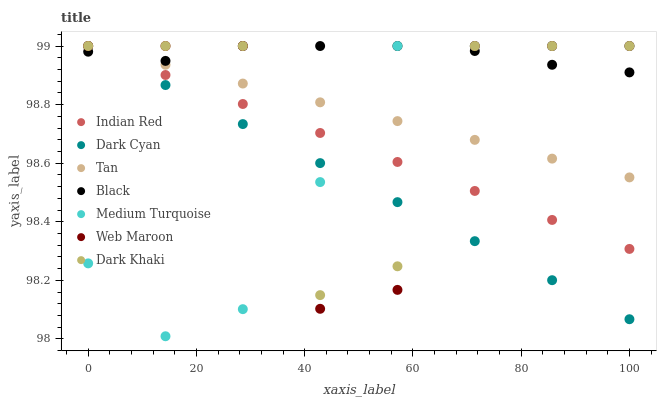Does Dark Cyan have the minimum area under the curve?
Answer yes or no. Yes. Does Black have the maximum area under the curve?
Answer yes or no. Yes. Does Web Maroon have the minimum area under the curve?
Answer yes or no. No. Does Web Maroon have the maximum area under the curve?
Answer yes or no. No. Is Tan the smoothest?
Answer yes or no. Yes. Is Web Maroon the roughest?
Answer yes or no. Yes. Is Dark Khaki the smoothest?
Answer yes or no. No. Is Dark Khaki the roughest?
Answer yes or no. No. Does Medium Turquoise have the lowest value?
Answer yes or no. Yes. Does Web Maroon have the lowest value?
Answer yes or no. No. Does Tan have the highest value?
Answer yes or no. Yes. Does Black intersect Indian Red?
Answer yes or no. Yes. Is Black less than Indian Red?
Answer yes or no. No. Is Black greater than Indian Red?
Answer yes or no. No. 